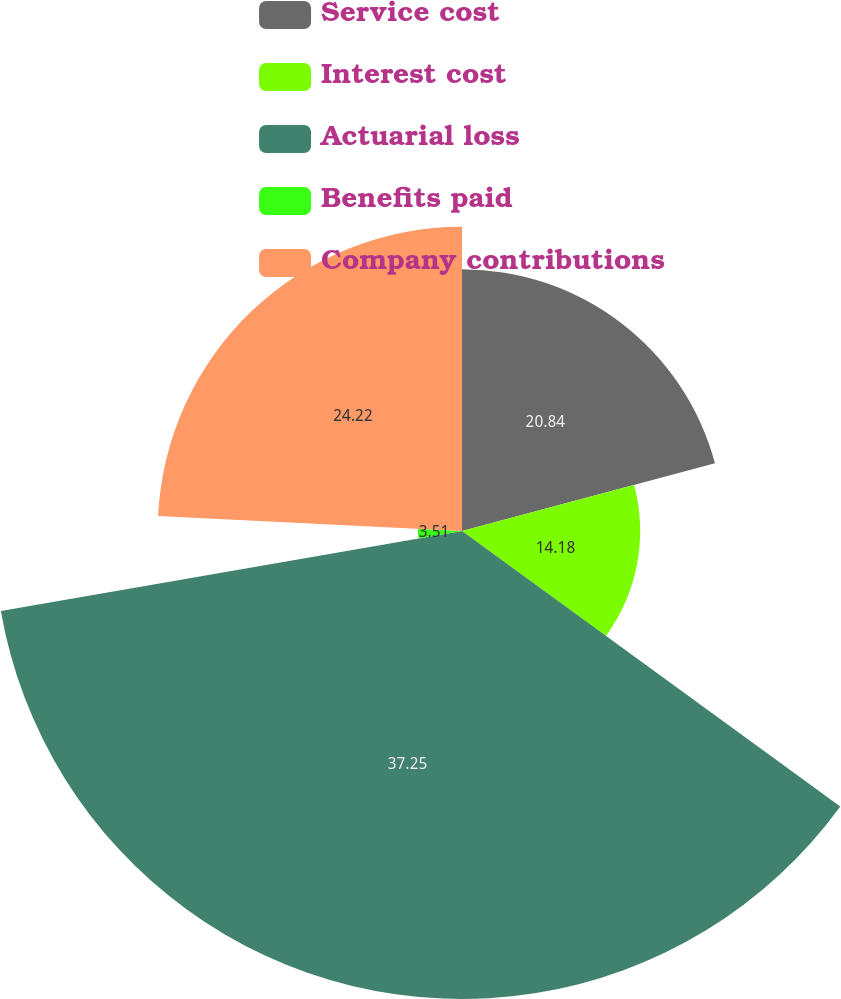Convert chart to OTSL. <chart><loc_0><loc_0><loc_500><loc_500><pie_chart><fcel>Service cost<fcel>Interest cost<fcel>Actuarial loss<fcel>Benefits paid<fcel>Company contributions<nl><fcel>20.84%<fcel>14.18%<fcel>37.25%<fcel>3.51%<fcel>24.22%<nl></chart> 